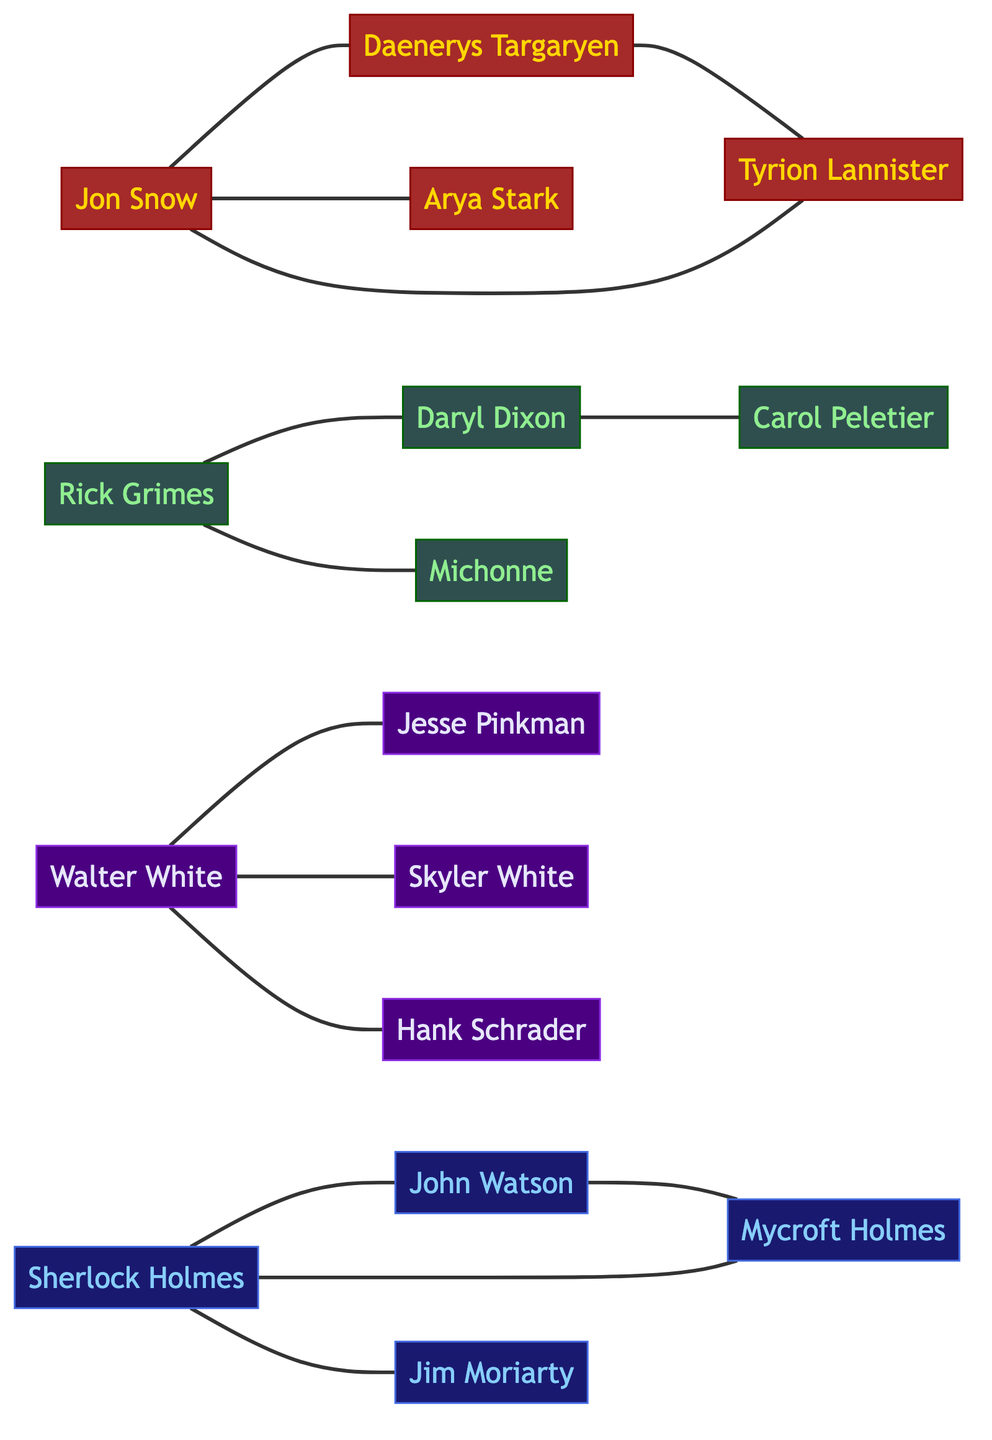What is the total number of nodes in the diagram? The diagram presents 16 unique characters (nodes) from various drama series. Simply counting all the individual nodes listed leads to a total of 16.
Answer: 16 Which actor from "Game of Thrones" is connected to both Daenerys Targaryen and Tyrion Lannister? Jon Snow has direct connections (edges) to both Daenerys Targaryen and Tyrion Lannister, which is visible in the diagram as a line connecting him to these two characters.
Answer: Jon Snow How many edges are there connecting characters from "Breaking Bad"? The characters from "Breaking Bad" (Walter White, Jesse Pinkman, Skyler White, Hank Schrader) have three direct connections between them (edges), which can be counted in the edges section of the diagram.
Answer: 3 Who is the central character related to both Sherlock Holmes and Mycroft Holmes? Sherlock Holmes is connected to Mycroft Holmes through a direct edge in the diagram, indicating their relationship, while they share a central node.
Answer: Sherlock Holmes What series features a character named Daryl Dixon? The character Daryl Dixon is part of "The Walking Dead," as indicated by the series label next to him in the diagram.
Answer: The Walking Dead Which two characters from "The Walking Dead" share a direct edge? Rick Grimes and Daryl Dixon are directly connected by an edge in the diagram, as shown by the line between them.
Answer: Rick Grimes and Daryl Dixon How many characters are connected to Walter White in "Breaking Bad"? Walter White has three connections: Jesse Pinkman, Skyler White, and Hank Schrader, which can be seen clearly around his node in the diagram, totaling three edges.
Answer: 3 Is there a relationship between Jim Moriarty and anyone else? Yes, Jim Moriarty has a direct edge connecting him to Sherlock Holmes, indicating their relationship in the diagram.
Answer: Sherlock Holmes Which character from "Sherlock" connects directly to both John Watson and Mycroft Holmes? Sherlock Holmes connects to both John Watson and Mycroft Holmes through direct edges in the diagram, making him the hub in that relationship chain.
Answer: Sherlock Holmes 